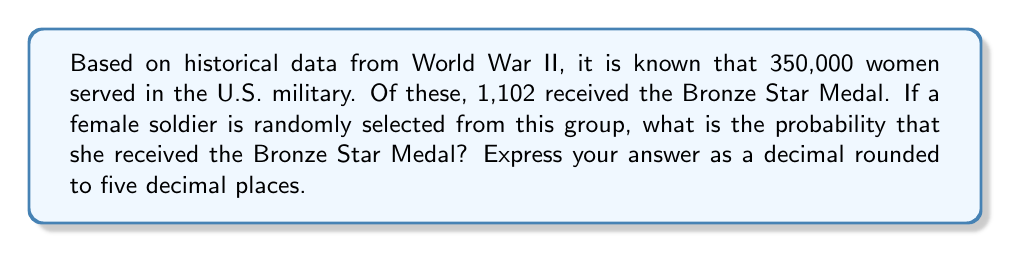Solve this math problem. To solve this problem, we need to use the concept of probability as the ratio of favorable outcomes to total possible outcomes.

1. Total number of women who served in the U.S. military during WWII: 350,000
2. Number of women who received the Bronze Star Medal: 1,102

The probability is calculated as:

$$ P(\text{Bronze Star}) = \frac{\text{Number of women who received Bronze Star}}{\text{Total number of women who served}} $$

$$ P(\text{Bronze Star}) = \frac{1,102}{350,000} $$

Using a calculator to divide:

$$ P(\text{Bronze Star}) = 0.0031485714... $$

Rounding to five decimal places:

$$ P(\text{Bronze Star}) \approx 0.00315 $$
Answer: 0.00315 